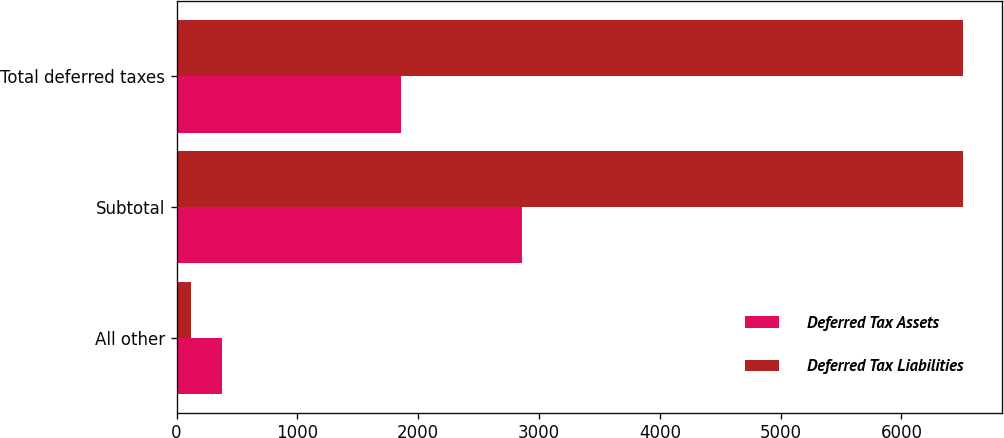Convert chart. <chart><loc_0><loc_0><loc_500><loc_500><stacked_bar_chart><ecel><fcel>All other<fcel>Subtotal<fcel>Total deferred taxes<nl><fcel>Deferred Tax Assets<fcel>374<fcel>2863<fcel>1860<nl><fcel>Deferred Tax Liabilities<fcel>116<fcel>6506<fcel>6506<nl></chart> 